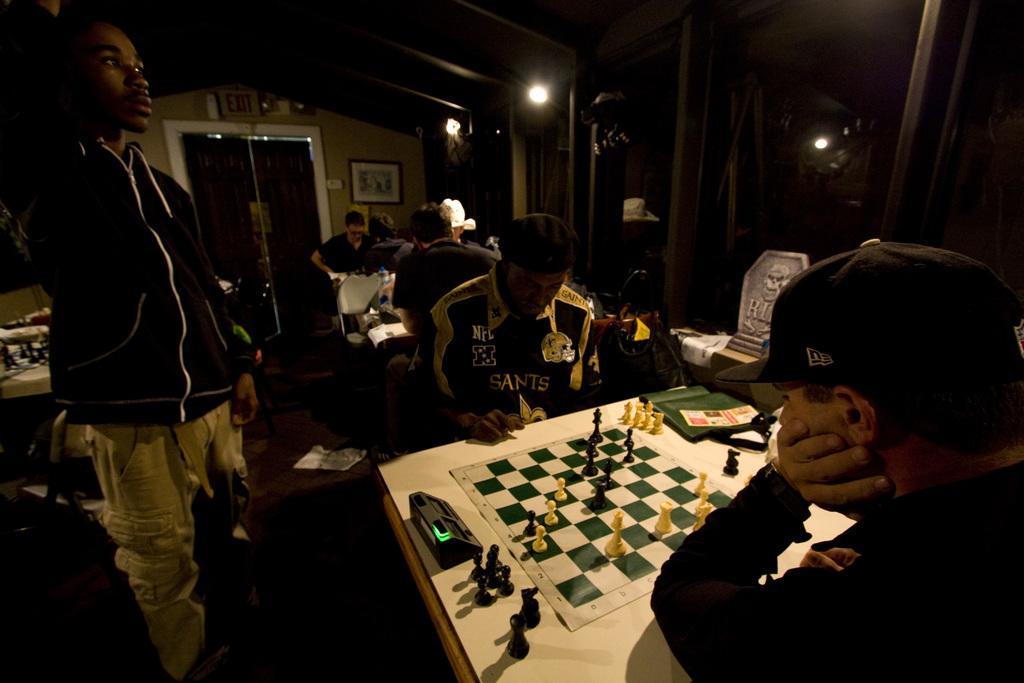In one or two sentences, can you explain what this image depicts? There is a group of people. They are sitting on a chair. They are playing a chess game. On the left side we have a person. He is standing. 